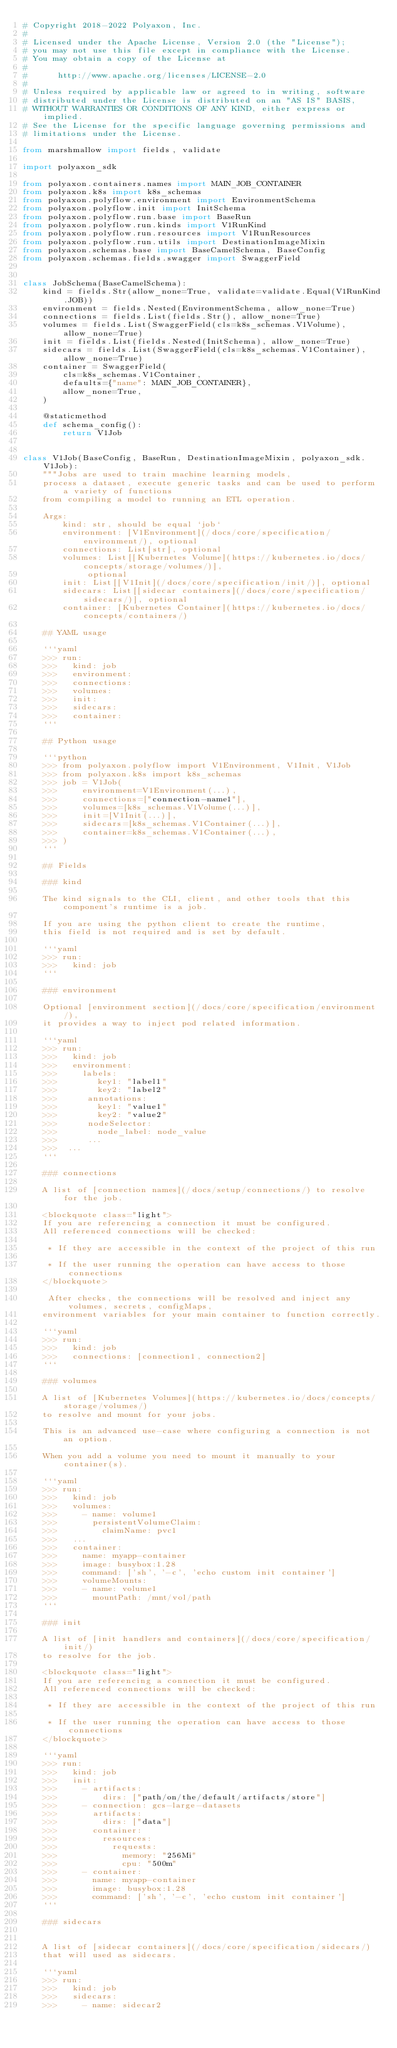Convert code to text. <code><loc_0><loc_0><loc_500><loc_500><_Python_># Copyright 2018-2022 Polyaxon, Inc.
#
# Licensed under the Apache License, Version 2.0 (the "License");
# you may not use this file except in compliance with the License.
# You may obtain a copy of the License at
#
#      http://www.apache.org/licenses/LICENSE-2.0
#
# Unless required by applicable law or agreed to in writing, software
# distributed under the License is distributed on an "AS IS" BASIS,
# WITHOUT WARRANTIES OR CONDITIONS OF ANY KIND, either express or implied.
# See the License for the specific language governing permissions and
# limitations under the License.

from marshmallow import fields, validate

import polyaxon_sdk

from polyaxon.containers.names import MAIN_JOB_CONTAINER
from polyaxon.k8s import k8s_schemas
from polyaxon.polyflow.environment import EnvironmentSchema
from polyaxon.polyflow.init import InitSchema
from polyaxon.polyflow.run.base import BaseRun
from polyaxon.polyflow.run.kinds import V1RunKind
from polyaxon.polyflow.run.resources import V1RunResources
from polyaxon.polyflow.run.utils import DestinationImageMixin
from polyaxon.schemas.base import BaseCamelSchema, BaseConfig
from polyaxon.schemas.fields.swagger import SwaggerField


class JobSchema(BaseCamelSchema):
    kind = fields.Str(allow_none=True, validate=validate.Equal(V1RunKind.JOB))
    environment = fields.Nested(EnvironmentSchema, allow_none=True)
    connections = fields.List(fields.Str(), allow_none=True)
    volumes = fields.List(SwaggerField(cls=k8s_schemas.V1Volume), allow_none=True)
    init = fields.List(fields.Nested(InitSchema), allow_none=True)
    sidecars = fields.List(SwaggerField(cls=k8s_schemas.V1Container), allow_none=True)
    container = SwaggerField(
        cls=k8s_schemas.V1Container,
        defaults={"name": MAIN_JOB_CONTAINER},
        allow_none=True,
    )

    @staticmethod
    def schema_config():
        return V1Job


class V1Job(BaseConfig, BaseRun, DestinationImageMixin, polyaxon_sdk.V1Job):
    """Jobs are used to train machine learning models,
    process a dataset, execute generic tasks and can be used to perform a variety of functions
    from compiling a model to running an ETL operation.

    Args:
        kind: str, should be equal `job`
        environment: [V1Environment](/docs/core/specification/environment/), optional
        connections: List[str], optional
        volumes: List[[Kubernetes Volume](https://kubernetes.io/docs/concepts/storage/volumes/)],
             optional
        init: List[[V1Init](/docs/core/specification/init/)], optional
        sidecars: List[[sidecar containers](/docs/core/specification/sidecars/)], optional
        container: [Kubernetes Container](https://kubernetes.io/docs/concepts/containers/)

    ## YAML usage

    ```yaml
    >>> run:
    >>>   kind: job
    >>>   environment:
    >>>   connections:
    >>>   volumes:
    >>>   init:
    >>>   sidecars:
    >>>   container:
    ```

    ## Python usage

    ```python
    >>> from polyaxon.polyflow import V1Environment, V1Init, V1Job
    >>> from polyaxon.k8s import k8s_schemas
    >>> job = V1Job(
    >>>     environment=V1Environment(...),
    >>>     connections=["connection-name1"],
    >>>     volumes=[k8s_schemas.V1Volume(...)],
    >>>     init=[V1Init(...)],
    >>>     sidecars=[k8s_schemas.V1Container(...)],
    >>>     container=k8s_schemas.V1Container(...),
    >>> )
    ```

    ## Fields

    ### kind

    The kind signals to the CLI, client, and other tools that this component's runtime is a job.

    If you are using the python client to create the runtime,
    this field is not required and is set by default.

    ```yaml
    >>> run:
    >>>   kind: job
    ```

    ### environment

    Optional [environment section](/docs/core/specification/environment/),
    it provides a way to inject pod related information.

    ```yaml
    >>> run:
    >>>   kind: job
    >>>   environment:
    >>>     labels:
    >>>        key1: "label1"
    >>>        key2: "label2"
    >>>      annotations:
    >>>        key1: "value1"
    >>>        key2: "value2"
    >>>      nodeSelector:
    >>>        node_label: node_value
    >>>      ...
    >>>  ...
    ```

    ### connections

    A list of [connection names](/docs/setup/connections/) to resolve for the job.

    <blockquote class="light">
    If you are referencing a connection it must be configured.
    All referenced connections will be checked:

     * If they are accessible in the context of the project of this run

     * If the user running the operation can have access to those connections
    </blockquote>

     After checks, the connections will be resolved and inject any volumes, secrets, configMaps,
    environment variables for your main container to function correctly.

    ```yaml
    >>> run:
    >>>   kind: job
    >>>   connections: [connection1, connection2]
    ```

    ### volumes

    A list of [Kubernetes Volumes](https://kubernetes.io/docs/concepts/storage/volumes/)
    to resolve and mount for your jobs.

    This is an advanced use-case where configuring a connection is not an option.

    When you add a volume you need to mount it manually to your container(s).

    ```yaml
    >>> run:
    >>>   kind: job
    >>>   volumes:
    >>>     - name: volume1
    >>>       persistentVolumeClaim:
    >>>         claimName: pvc1
    >>>   ...
    >>>   container:
    >>>     name: myapp-container
    >>>     image: busybox:1.28
    >>>     command: ['sh', '-c', 'echo custom init container']
    >>>     volumeMounts:
    >>>     - name: volume1
    >>>       mountPath: /mnt/vol/path
    ```

    ### init

    A list of [init handlers and containers](/docs/core/specification/init/)
    to resolve for the job.

    <blockquote class="light">
    If you are referencing a connection it must be configured.
    All referenced connections will be checked:

     * If they are accessible in the context of the project of this run

     * If the user running the operation can have access to those connections
    </blockquote>

    ```yaml
    >>> run:
    >>>   kind: job
    >>>   init:
    >>>     - artifacts:
    >>>         dirs: ["path/on/the/default/artifacts/store"]
    >>>     - connection: gcs-large-datasets
    >>>       artifacts:
    >>>         dirs: ["data"]
    >>>       container:
    >>>         resources:
    >>>           requests:
    >>>             memory: "256Mi"
    >>>             cpu: "500m"
    >>>     - container:
    >>>       name: myapp-container
    >>>       image: busybox:1.28
    >>>       command: ['sh', '-c', 'echo custom init container']
    ```

    ### sidecars


    A list of [sidecar containers](/docs/core/specification/sidecars/)
    that will used as sidecars.

    ```yaml
    >>> run:
    >>>   kind: job
    >>>   sidecars:
    >>>     - name: sidecar2</code> 